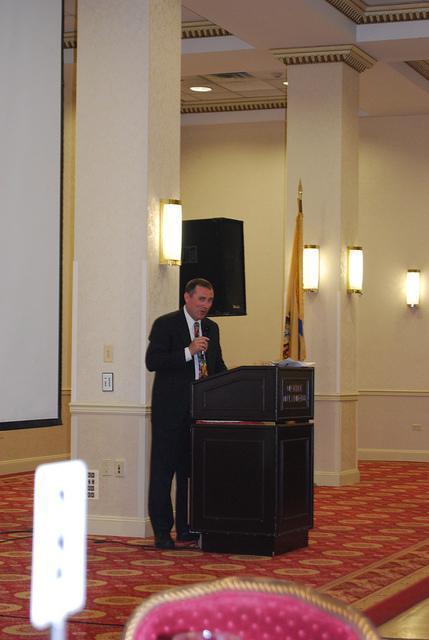How many sconces are visible?
Give a very brief answer. 4. How many people are there?
Give a very brief answer. 1. How many slices of pizza are left uneaten?
Give a very brief answer. 0. 